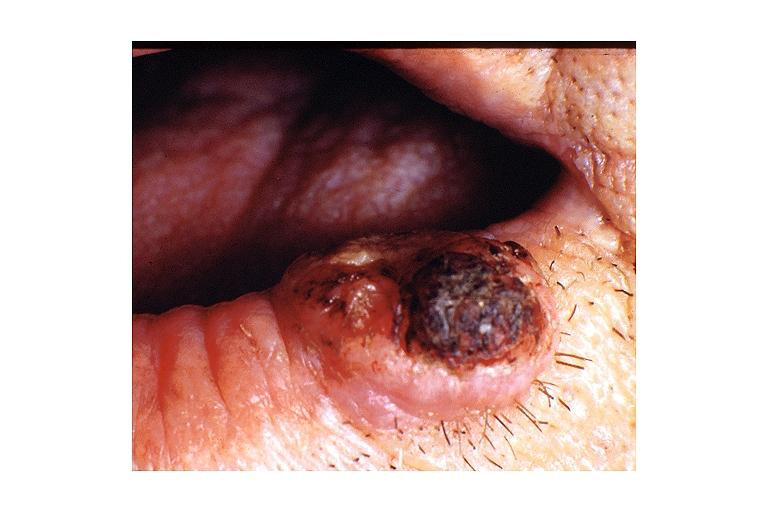s small intestine present?
Answer the question using a single word or phrase. No 